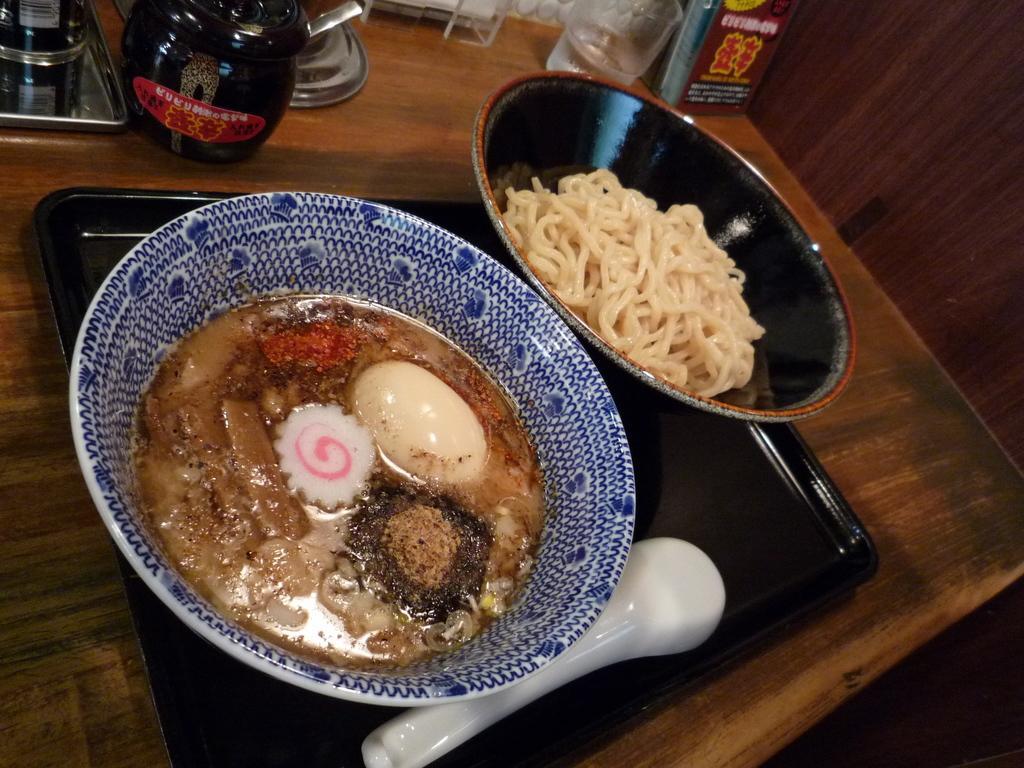Describe this image in one or two sentences. In this image we can see two different food items are present in different bowls. The bowls are in the black color tray with one spoon. The tray is on the wooden surface. At the top of the image, we can see utensils, container, kettle, tray and a box. 